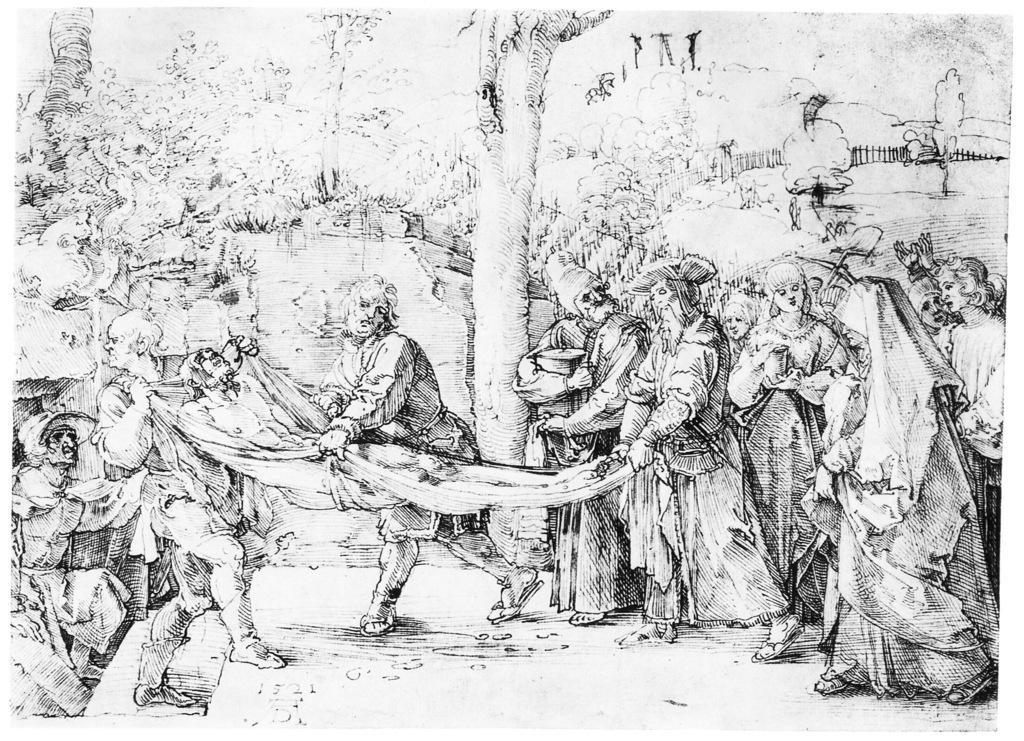What type of art is present in the image? The image contains art, but the specific type or medium is not mentioned. What can be seen in the background of the image? There are trees in the background of the image. How many people are visible in the image? There are people standing in the image. What are some people doing in the image? Some people are holding a man with the help of a cloth. Which direction is north in the image? There is no information provided about the direction of north in the image. Can you tell me how many seeds are visible in the image? There is no mention of seeds in the image. 